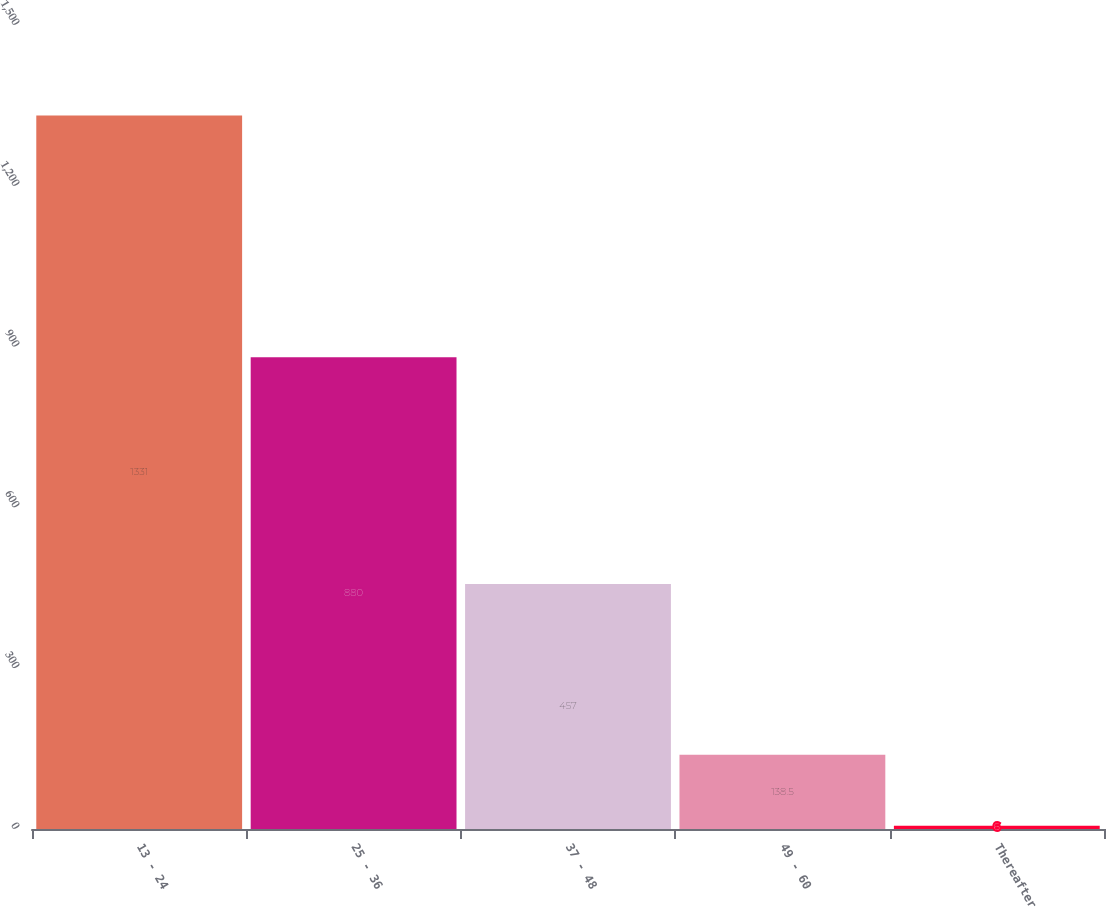<chart> <loc_0><loc_0><loc_500><loc_500><bar_chart><fcel>13 - 24<fcel>25 - 36<fcel>37 - 48<fcel>49 - 60<fcel>Thereafter<nl><fcel>1331<fcel>880<fcel>457<fcel>138.5<fcel>6<nl></chart> 